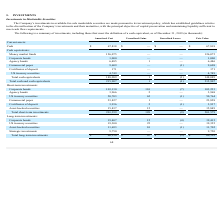According to Cornerstone Ondemand's financial document, What is the principal objective of the company's investments? capital preservation and maintaining liquidity sufficient to meet cash flow requirements.. The document states: "their maturities, with the principal objective of capital preservation and maintaining liquidity sufficient to meet cash flow requirements...." Also, What was the fair value amount of cash? According to the financial document, $67,818 (in thousands). The relevant text states: "Cash $ 67,818 $ — $ — $ 67,818..." Also, What was the fair value of corporate bonds? According to the financial document, 1,000 (in thousands). The relevant text states: "Corporate bonds 1,000 — — 1,000..." Also, can you calculate: What percentage of fair value total cash equivalents consist of agency bonds? Based on the calculation: (6,485/148,089), the result is 4.38 (percentage). This is based on the information: "Agency bonds 6,485 1 — 6,486 Total cash equivalents 148,089 1 (1) 148,089..." The key data points involved are: 148,089, 6,485. Also, can you calculate: What percentage of total unrealised gains for short-term investments consist of US treasury securities? Based on the calculation: (62/189), the result is 32.8 (percentage). This is based on the information: "US treasury securities 50,703 62 (1) 50,764 Total short-term investments 201,399 189 (9) 201,579..." The key data points involved are: 189, 62. Also, can you calculate: What is the total amortized cost of agency bonds and corporate bonds? Based on the calculation: 6,485+9,609, the result is 16094 (in thousands). This is based on the information: "Agency bonds 6,485 1 — 6,486 Commercial paper 9,609 — (1) 9,608..." The key data points involved are: 6,485, 9,609. 